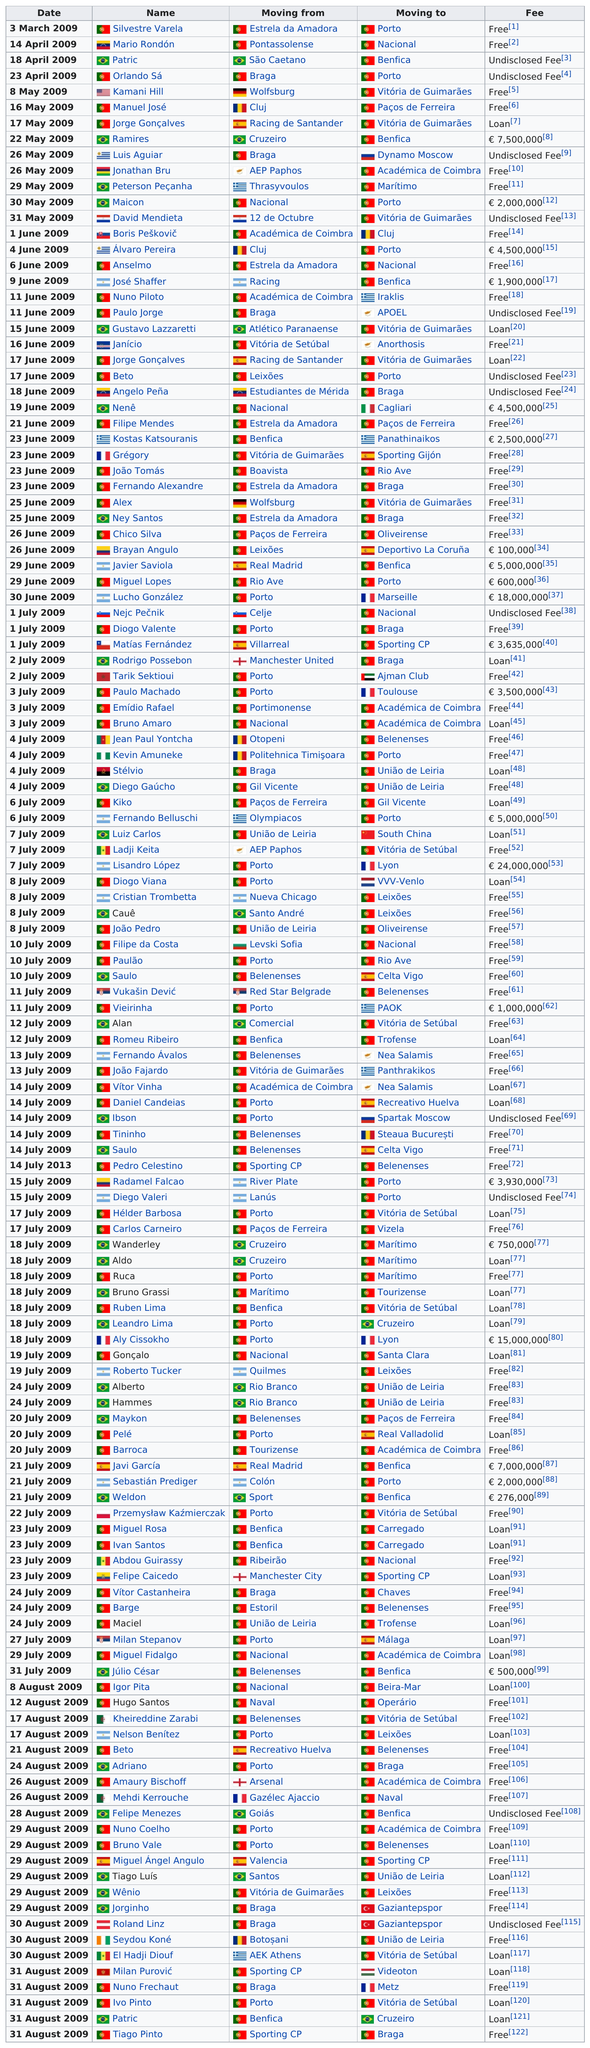Draw attention to some important aspects in this diagram. The previous name of Orlando Sá is Patricio. On April 1st, 2009, Patricio was the only Brazilian who transferred. On May 30, 2009, the next transfer after Maico was David Mendieta. Kamani Hill was transferred immediately before by Orlando Sá. The next transfer after Silvestre Varela was Mario Rondón. 